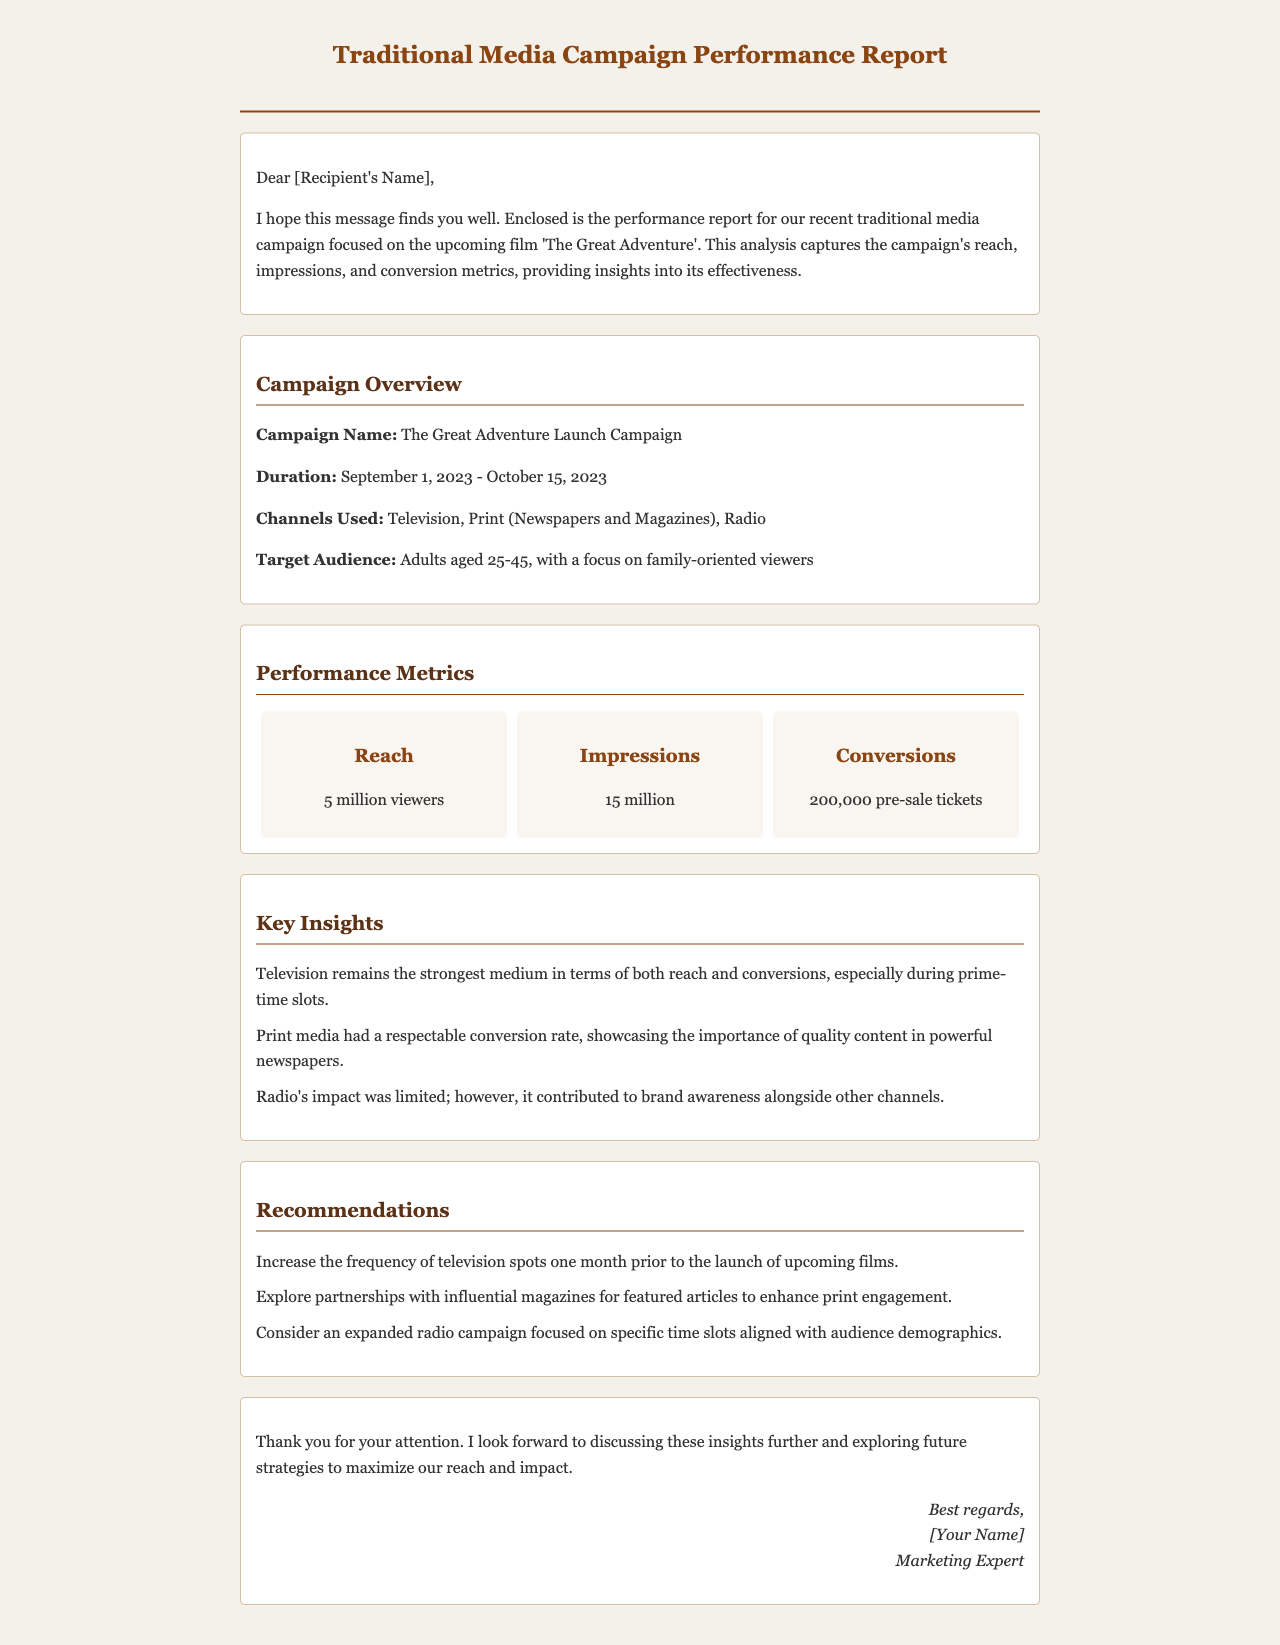What is the campaign name? The campaign name is mentioned in the campaign overview section.
Answer: The Great Adventure Launch Campaign What was the duration of the campaign? The duration of the campaign is provided in the campaign overview section.
Answer: September 1, 2023 - October 15, 2023 How many viewers did the campaign reach? The reach figure can be found under the performance metrics section.
Answer: 5 million viewers What was the total number of impressions? The total impressions are specified in the performance metrics section.
Answer: 15 million How many pre-sale tickets were converted? The conversion figure is listed in the performance metrics section.
Answer: 200,000 pre-sale tickets Which medium was the strongest in terms of reach? The key insights section discusses the effectiveness of various media channels.
Answer: Television What recommendation was made regarding television spots? The recommendations section outlines suggestions for increasing media effectiveness.
Answer: Increase the frequency of television spots one month prior to the launch of upcoming films Which media type had a respectable conversion rate? The key insights section provides specific details about media performance.
Answer: Print media What is the target audience for the campaign? The target audience details can be found in the campaign overview section.
Answer: Adults aged 25-45, with a focus on family-oriented viewers 